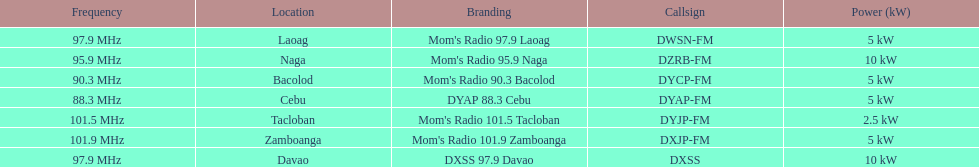What is the only radio station with a frequency below 90 mhz? DYAP 88.3 Cebu. 